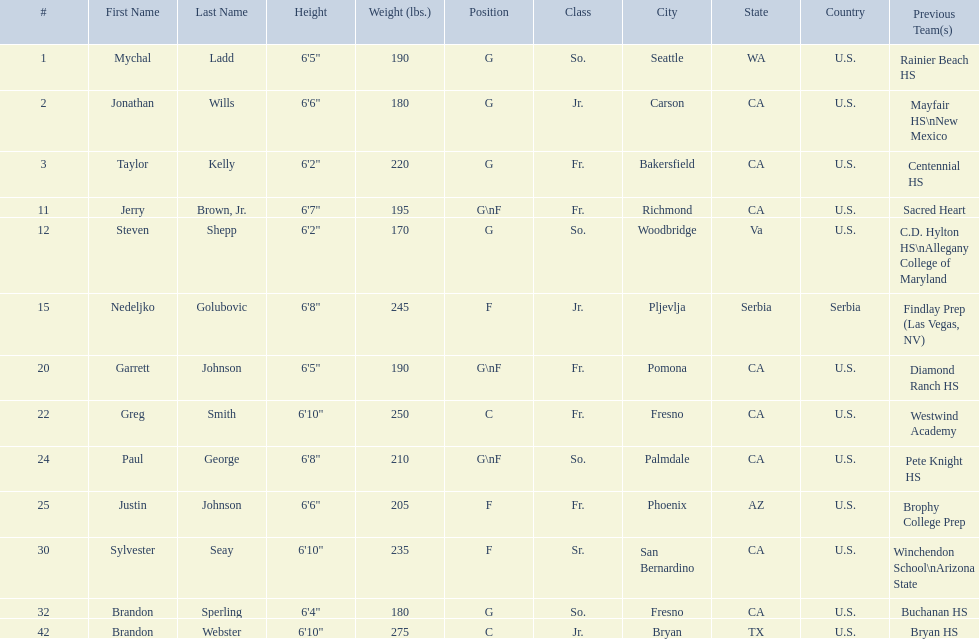Who are all of the players? Mychal Ladd, Jonathan Wills, Taylor Kelly, Jerry Brown, Jr., Steven Shepp, Nedeljko Golubovic, Garrett Johnson, Greg Smith, Paul George, Justin Johnson, Sylvester Seay, Brandon Sperling, Brandon Webster. What are their heights? 6'5", 6'6", 6'2", 6'7", 6'2", 6'8", 6'5", 6'10", 6'8", 6'6", 6'10", 6'4", 6'10". Along with taylor kelly, which other player is shorter than 6'3? Steven Shepp. 